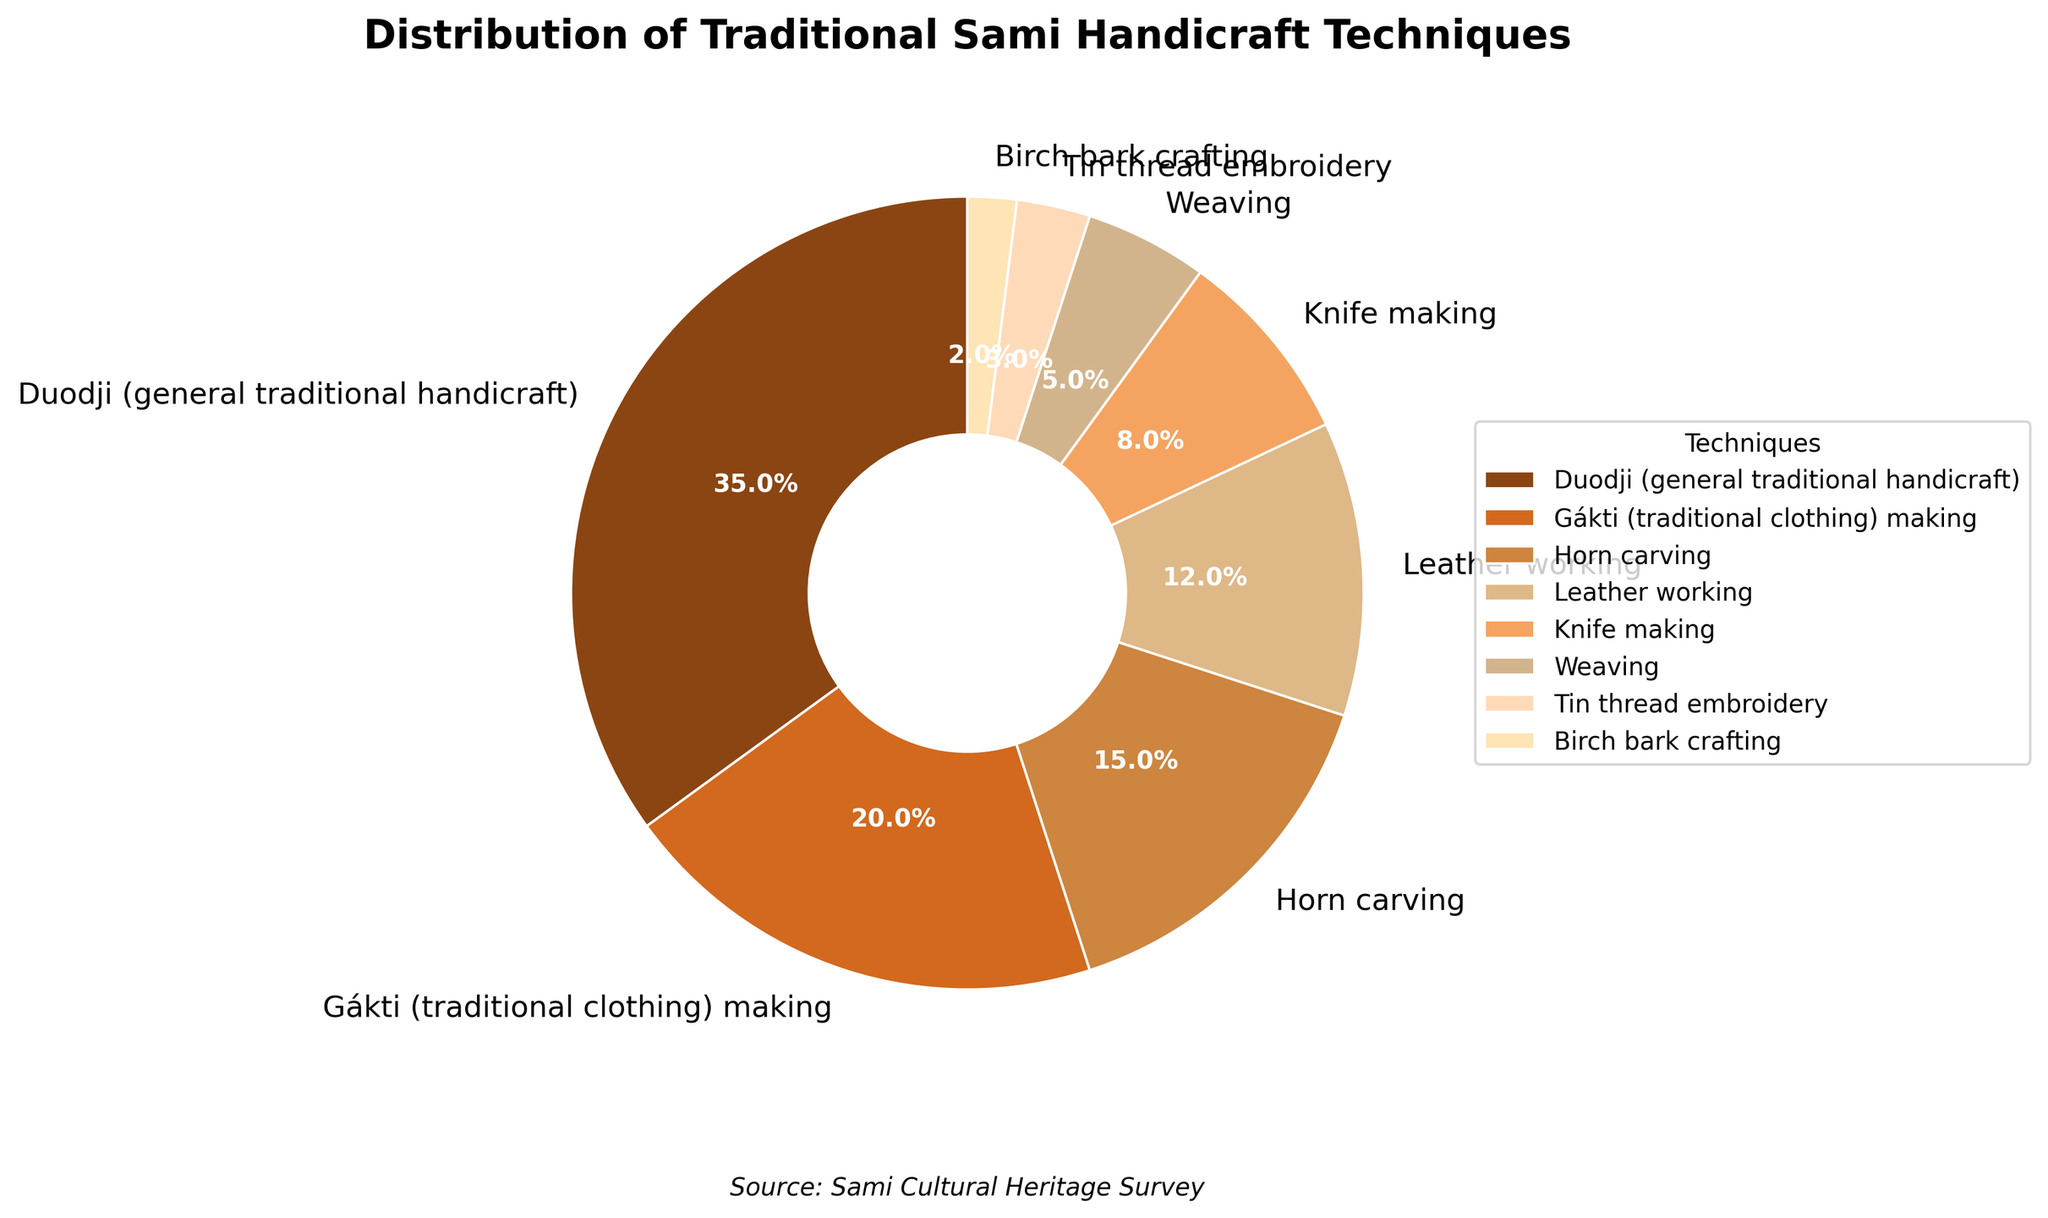What is the most common Sami handicraft technique practiced among reindeer herders? The pie chart shows different slices representing each handicraft technique. The largest slice belongs to Duodji (general traditional handicraft), which has the highest percentage at 35%.
Answer: Duodji (general traditional handicraft) Which Sami handicraft technique is practiced least among reindeer herders? The smallest slice in the pie chart represents Birch bark crafting, with a percentage of 2%.
Answer: Birch bark crafting What is the combined percentage of leather working and knife making? Look at the segments for leather working (12%) and knife making (8%) and add them together: 12% + 8% = 20%.
Answer: 20% How does the percentage of Gákti (traditional clothing) making compare to the combined percentage of weaving and tin thread embroidery? Gákti making is 20%. Weaving is 5% and tin thread embroidery is 3%. Adding the latter two gives 5% + 3% = 8%. Thus, Gákti making has a higher percentage.
Answer: Gákti making is higher What is the percentage difference between horn carving and leather working? Horn carving is at 15% and leather working is at 12%. Subtract 12% from 15% to find the difference: 15% - 12% = 3%.
Answer: 3% Which handicraft technique has a slightly greater percentage than weaving? Weaving has a percentage of 5%. The next smallest percentage greater than 5% is knife making, which is at 8%.
Answer: Knife making Which category occupies the second-largest slice in the pie chart? The second-largest slice after Duodji (35%) is for Gákti (traditional clothing) making, with a percentage of 20%.
Answer: Gákti (traditional clothing) making How many more percentage points does general traditional handicraft hold compared to horn carving? Duodji holds 35% while horn carving holds 15%. Calculate the difference: 35% - 15% = 20%.
Answer: 20% What is the median value of the percentage distribution across all handicraft techniques listed? First sort the percentages in ascending order: 2%, 3%, 5%, 8%, 12%, 15%, 20%, 35%. Since there are 8 values, the median is the average of the 4th and 5th values: (8% + 12%) / 2 = 10%.
Answer: 10% What is the combined percentage of techniques involving wearable items (Gákti, tin thread embroidery, leather working) and how does it compare to all non-wearable techniques? Calculate the sum of the percentages for Gákti (20%), tin thread embroidery (3%), and leather working (12%): 20% + 3% + 12% = 35%. The remaining techniques: 35% - 35% = 44%. Compare both sums: 35% vs 65%. Wearable items have a lower total.
Answer: Wearable items have a lower total 